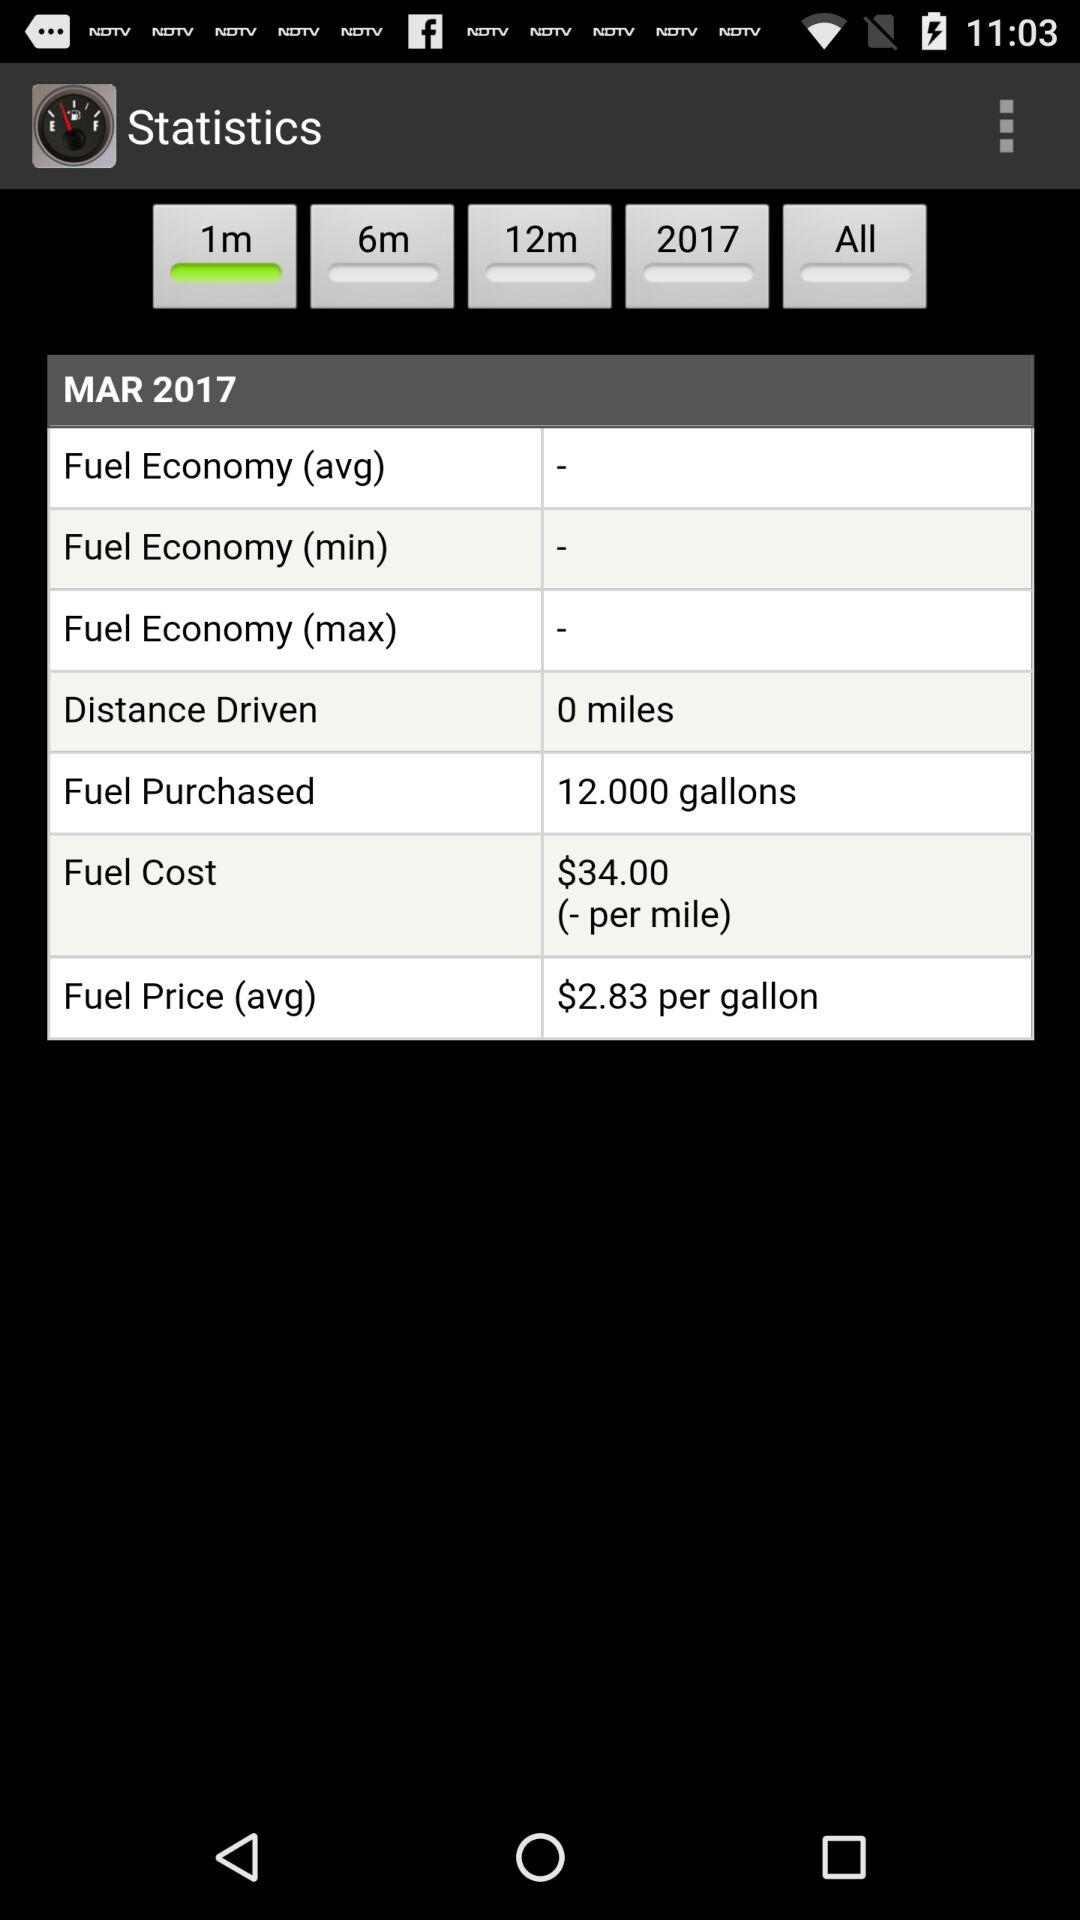What is the average price of fuel? The average price of fuel is $2.83 per gallon. 